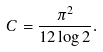<formula> <loc_0><loc_0><loc_500><loc_500>C = \frac { \pi ^ { 2 } } { 1 2 \log 2 } .</formula> 